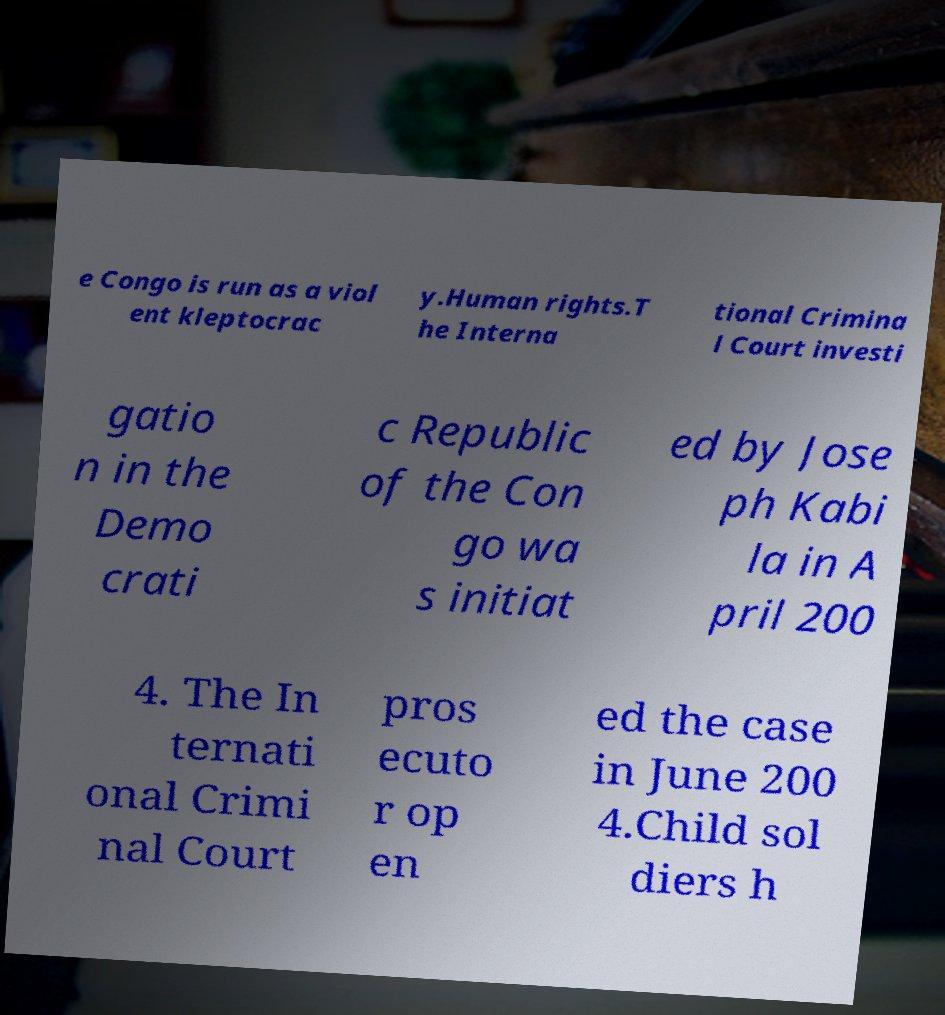Please read and relay the text visible in this image. What does it say? e Congo is run as a viol ent kleptocrac y.Human rights.T he Interna tional Crimina l Court investi gatio n in the Demo crati c Republic of the Con go wa s initiat ed by Jose ph Kabi la in A pril 200 4. The In ternati onal Crimi nal Court pros ecuto r op en ed the case in June 200 4.Child sol diers h 